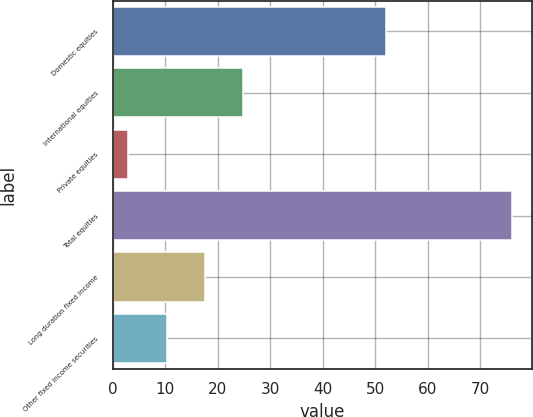Convert chart to OTSL. <chart><loc_0><loc_0><loc_500><loc_500><bar_chart><fcel>Domestic equities<fcel>International equities<fcel>Private equities<fcel>Total equities<fcel>Long duration fixed income<fcel>Other fixed income securities<nl><fcel>52<fcel>24.9<fcel>3<fcel>76<fcel>17.6<fcel>10.3<nl></chart> 